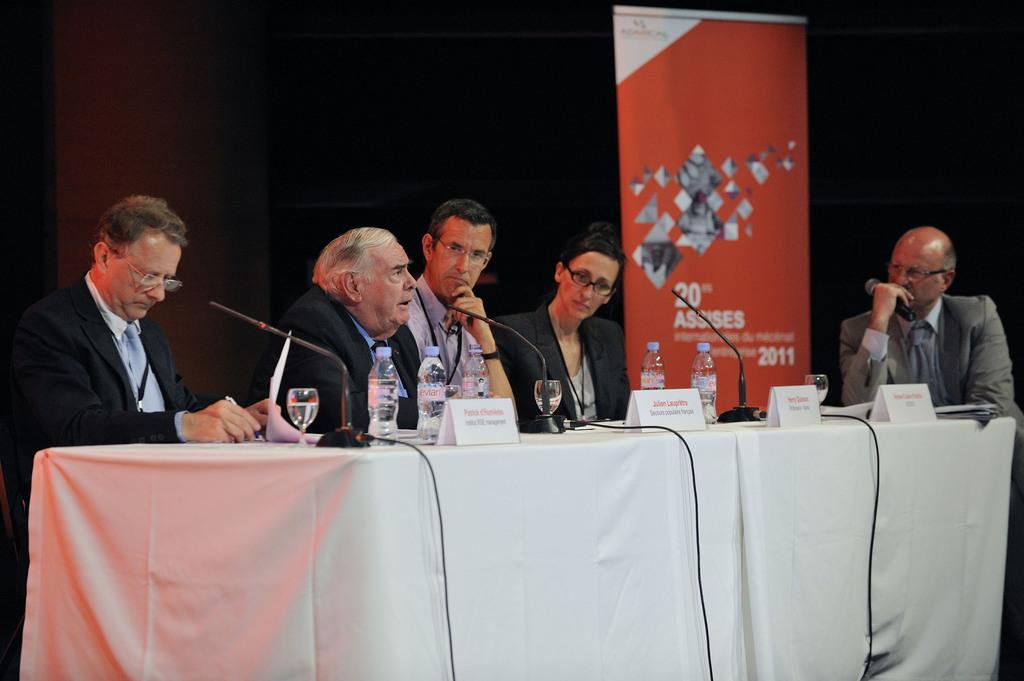How many people are sitting on the chair in the image? There are five people sitting on a chair in the image. What is present on the table in the image? There is a glass, water bottles, and a microphone on the table in the image. What can be seen in the background of the image? There is a banner visible in the background. What type of spoon is being used to stir the water in the glass? There is no spoon visible in the image, and the glass does not contain any water. 